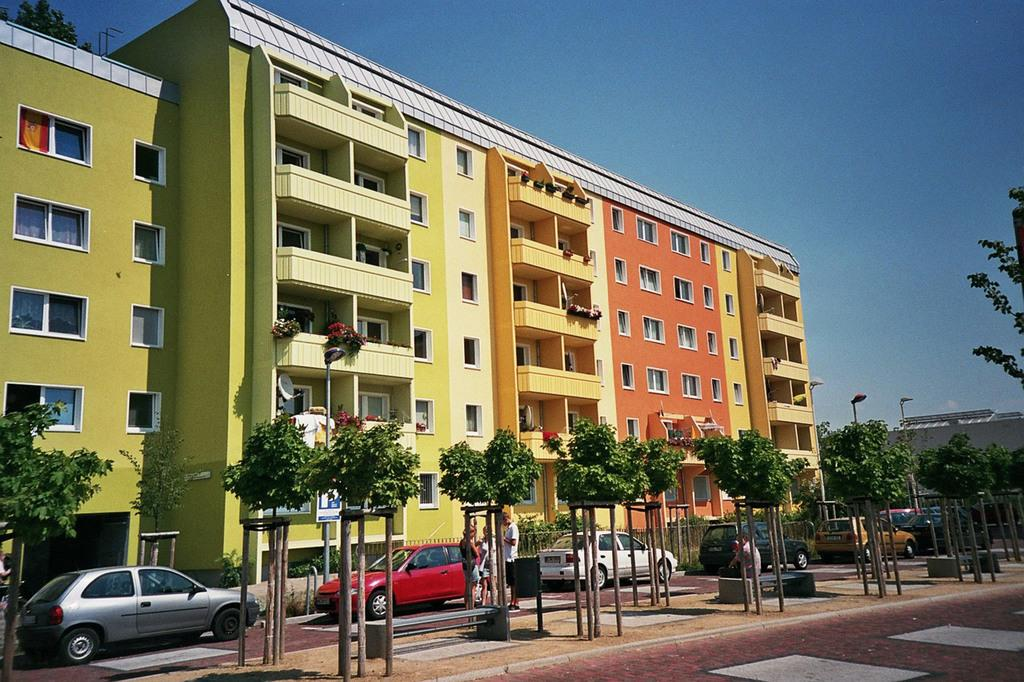What can be seen on the left side of the image? There are buildings, trees, cars, and people on the left side of the image. What features are present on the buildings? There are windows on the buildings on the left side of the image. What is located in the middle of the image? There are trees, cars, a roadhouse, street lights, and the sky visible in the middle of the image. What is the carpenter teaching the limit in the image? There is no carpenter or teaching activity present in the image. What type of woodworking tools can be seen in the image? There are no woodworking tools visible in the image. 